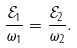<formula> <loc_0><loc_0><loc_500><loc_500>\frac { \mathcal { E } _ { 1 } } { \omega _ { 1 } } = \frac { \mathcal { E } _ { 2 } } { \omega _ { 2 } } .</formula> 